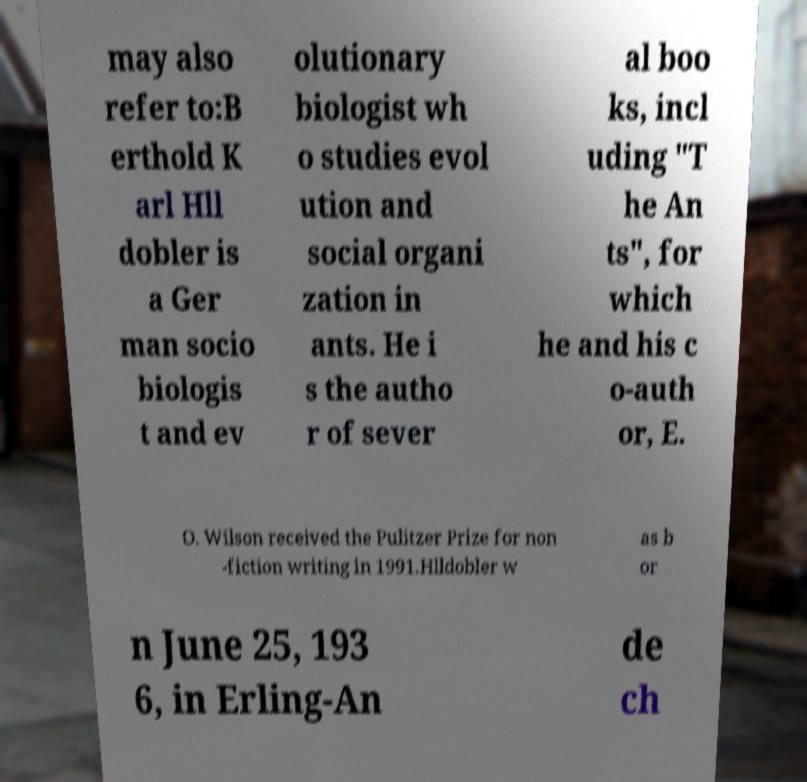Can you accurately transcribe the text from the provided image for me? may also refer to:B erthold K arl Hll dobler is a Ger man socio biologis t and ev olutionary biologist wh o studies evol ution and social organi zation in ants. He i s the autho r of sever al boo ks, incl uding "T he An ts", for which he and his c o-auth or, E. O. Wilson received the Pulitzer Prize for non -fiction writing in 1991.Hlldobler w as b or n June 25, 193 6, in Erling-An de ch 